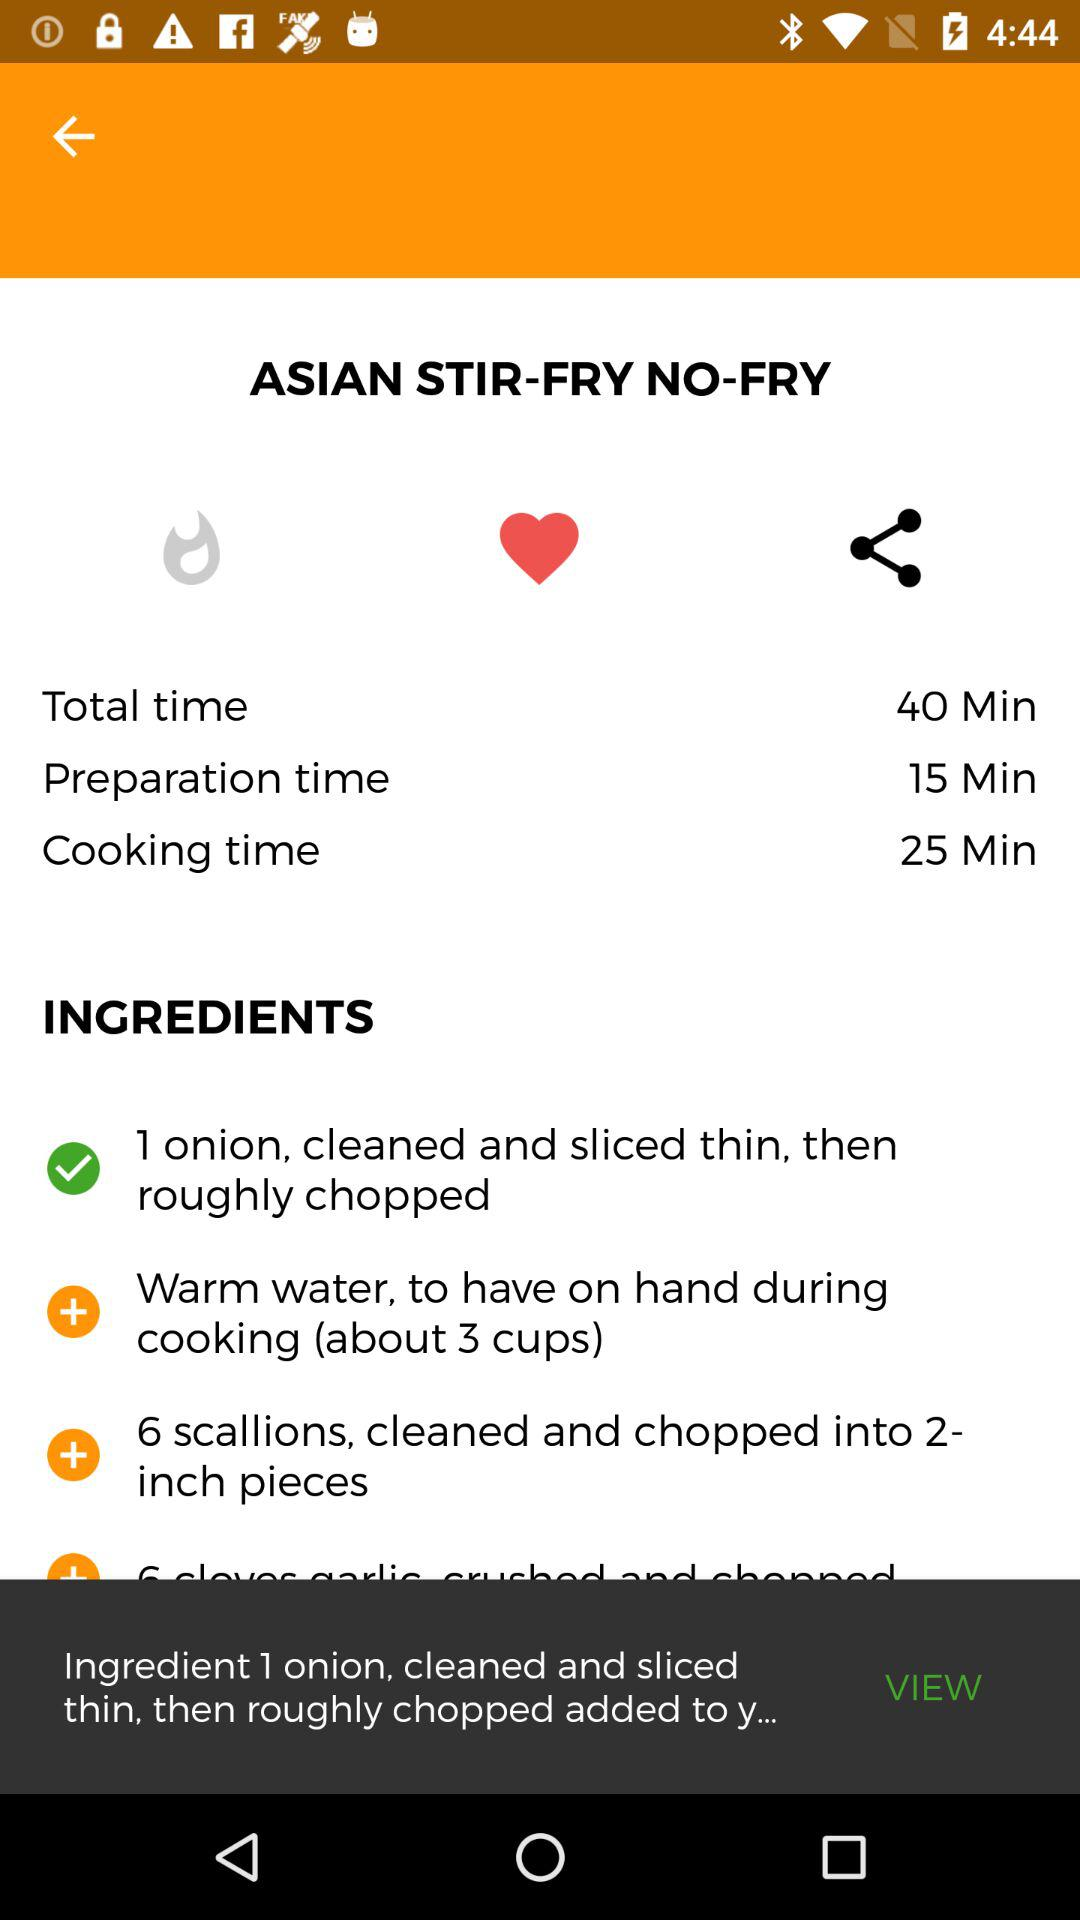What is the preparation time? The preparation time is 15 minutes. 